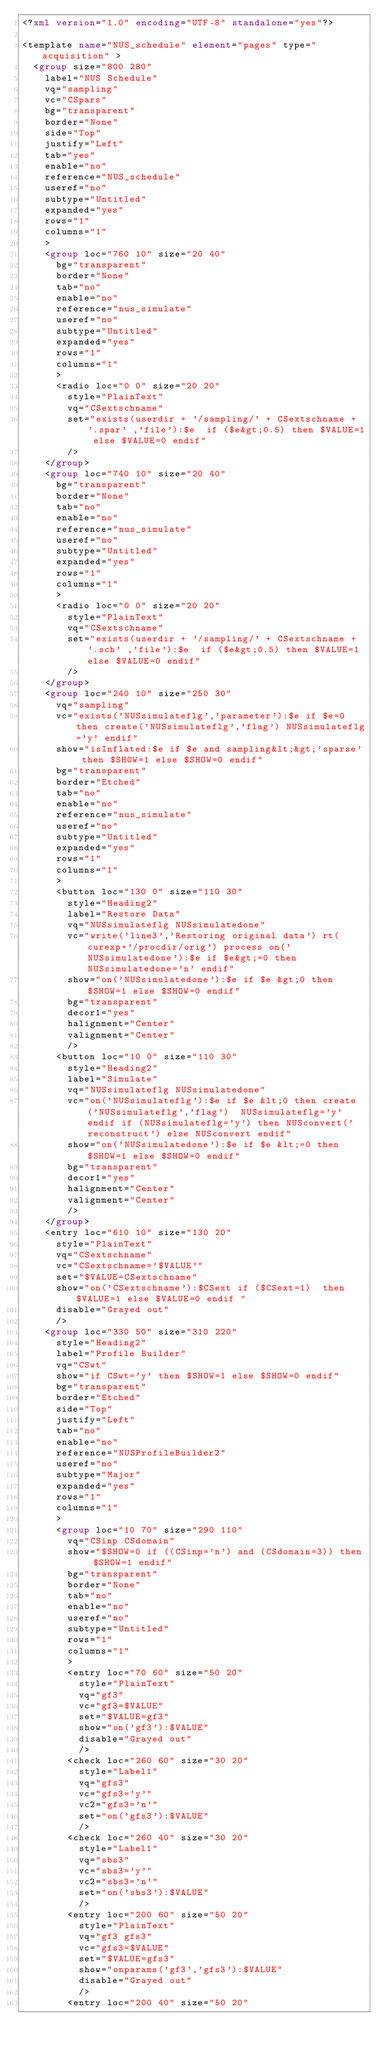Convert code to text. <code><loc_0><loc_0><loc_500><loc_500><_XML_><?xml version="1.0" encoding="UTF-8" standalone="yes"?>

<template name="NUS_schedule" element="pages" type="acquisition" >
  <group size="800 280"
    label="NUS Schedule"
    vq="sampling"
    vc="CSpars"
    bg="transparent"
    border="None"
    side="Top"
    justify="Left"
    tab="yes"
    enable="no"
    reference="NUS_schedule"
    useref="no"
    subtype="Untitled"
    expanded="yes"
    rows="1"
    columns="1"
    >
    <group loc="760 10" size="20 40"
      bg="transparent"
      border="None"
      tab="no"
      enable="no"
      reference="nus_simulate"
      useref="no"
      subtype="Untitled"
      expanded="yes"
      rows="1"
      columns="1"
      >
      <radio loc="0 0" size="20 20"
        style="PlainText"
        vq="CSextschname"
        set="exists(userdir + '/sampling/' + CSextschname + '.spar' ,'file'):$e  if ($e&gt;0.5) then $VALUE=1 else $VALUE=0 endif"
        />
    </group>
    <group loc="740 10" size="20 40"
      bg="transparent"
      border="None"
      tab="no"
      enable="no"
      reference="nus_simulate"
      useref="no"
      subtype="Untitled"
      expanded="yes"
      rows="1"
      columns="1"
      >
      <radio loc="0 0" size="20 20"
        style="PlainText"
        vq="CSextschname"
        set="exists(userdir + '/sampling/' + CSextschname + '.sch' ,'file'):$e  if ($e&gt;0.5) then $VALUE=1 else $VALUE=0 endif"
        />
    </group>
    <group loc="240 10" size="250 30"
      vq="sampling"
      vc="exists('NUSsimulateflg','parameter'):$e if $e=0 then create('NUSsimulateflg','flag') NUSsimulateflg='y' endif"
      show="isInflated:$e if $e and sampling&lt;&gt;'sparse' then $SHOW=1 else $SHOW=0 endif"
      bg="transparent"
      border="Etched"
      tab="no"
      enable="no"
      reference="nus_simulate"
      useref="no"
      subtype="Untitled"
      expanded="yes"
      rows="1"
      columns="1"
      >
      <button loc="130 0" size="110 30"
        style="Heading2"
        label="Restore Data"
        vq="NUSsimulateflg NUSsimulatedone"
        vc="write('line3','Restoring original data') rt(curexp+'/procdir/orig') process on('NUSsimulatedone'):$e if $e&gt;=0 then NUSsimulatedone='n' endif"
        show="on('NUSsimulatedone'):$e if $e &gt;0 then $SHOW=1 else $SHOW=0 endif"
        bg="transparent"
        decor1="yes"
        halignment="Center"
        valignment="Center"
        />
      <button loc="10 0" size="110 30"
        style="Heading2"
        label="Simulate"
        vq="NUSsimulateflg NUSsimulatedone"
        vc="on('NUSsimulateflg'):$e if $e &lt;0 then create('NUSsimulateflg','flag')  NUSsimulateflg='y' endif if (NUSsimulateflg='y') then NUSconvert('reconstruct') else NUSconvert endif"
        show="on('NUSsimulatedone'):$e if $e &lt;=0 then $SHOW=1 else $SHOW=0 endif"
        bg="transparent"
        decor1="yes"
        halignment="Center"
        valignment="Center"
        />
    </group>
    <entry loc="610 10" size="130 20"
      style="PlainText"
      vq="CSextschname"
      vc="CSextschname='$VALUE'"
      set="$VALUE=CSextschname"
      show="on('CSextschname'):$CSext if ($CSext=1)  then $VALUE=1 else $VALUE=0 endif "
      disable="Grayed out"
      />
    <group loc="330 50" size="310 220"
      style="Heading2"
      label="Profile Builder"
      vq="CSwt"
      show="if CSwt='y' then $SHOW=1 else $SHOW=0 endif"
      bg="transparent"
      border="Etched"
      side="Top"
      justify="Left"
      tab="no"
      enable="no"
      reference="NUSProfileBuilder2"
      useref="no"
      subtype="Major"
      expanded="yes"
      rows="1"
      columns="1"
      >
      <group loc="10 70" size="290 110"
        vq="CSinp CSdomain"
        show="$SHOW=0 if ((CSinp='n') and (CSdomain=3)) then $SHOW=1 endif"
        bg="transparent"
        border="None"
        tab="no"
        enable="no"
        useref="no"
        subtype="Untitled"
        rows="1"
        columns="1"
        >
        <entry loc="70 60" size="50 20"
          style="PlainText"
          vq="gf3"
          vc="gf3=$VALUE"
          set="$VALUE=gf3"
          show="on('gf3'):$VALUE"
          disable="Grayed out"
          />
        <check loc="260 60" size="30 20"
          style="Label1"
          vq="gfs3"
          vc="gfs3='y'"
          vc2="gfs3='n'"
          set="on('gfs3'):$VALUE"
          />
        <check loc="260 40" size="30 20"
          style="Label1"
          vq="sbs3"
          vc="sbs3='y'"
          vc2="sbs3='n'"
          set="on('sbs3'):$VALUE"
          />
        <entry loc="200 60" size="50 20"
          style="PlainText"
          vq="gf3 gfs3"
          vc="gfs3=$VALUE"
          set="$VALUE=gfs3"
          show="onparams('gf3','gfs3'):$VALUE"
          disable="Grayed out"
          />
        <entry loc="200 40" size="50 20"</code> 